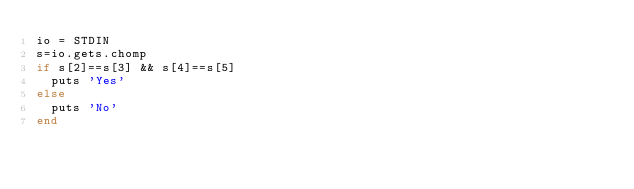<code> <loc_0><loc_0><loc_500><loc_500><_Ruby_>io = STDIN
s=io.gets.chomp
if s[2]==s[3] && s[4]==s[5]
  puts 'Yes'
else
  puts 'No'
end
</code> 